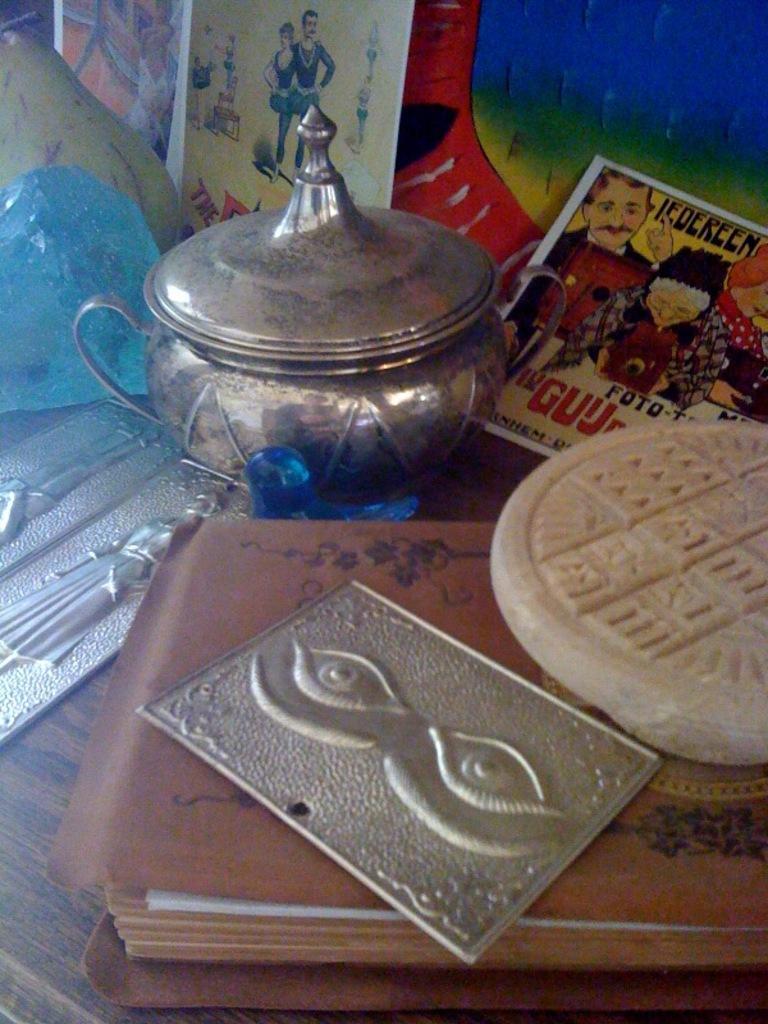Describe this image in one or two sentences. In this image there is a water vessel, book, cards and a few other objects on the table. 